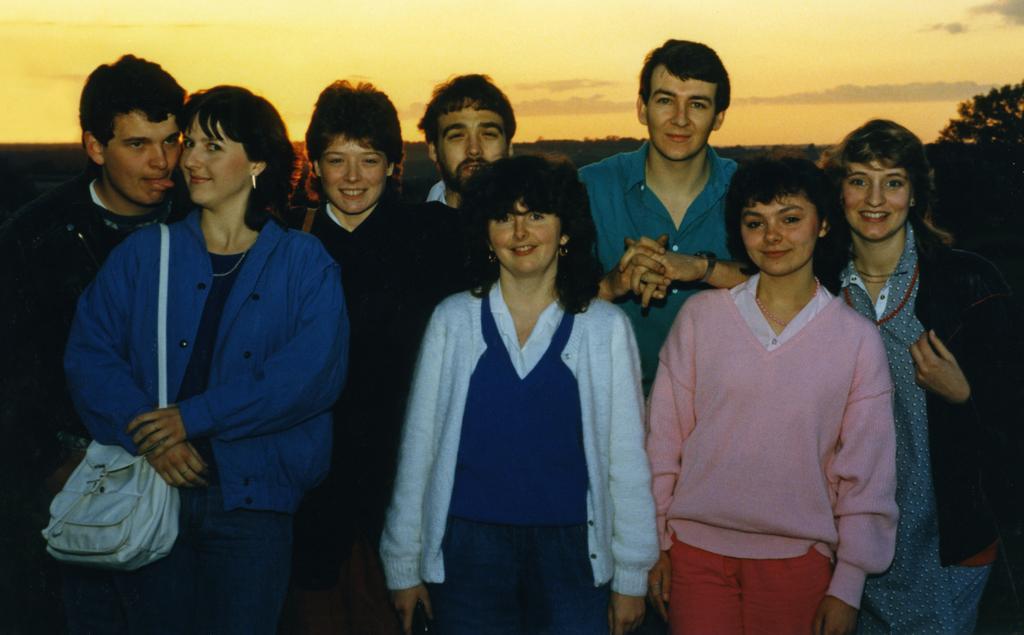In one or two sentences, can you explain what this image depicts? In this image, we can see group of people and it is almost sunset. 